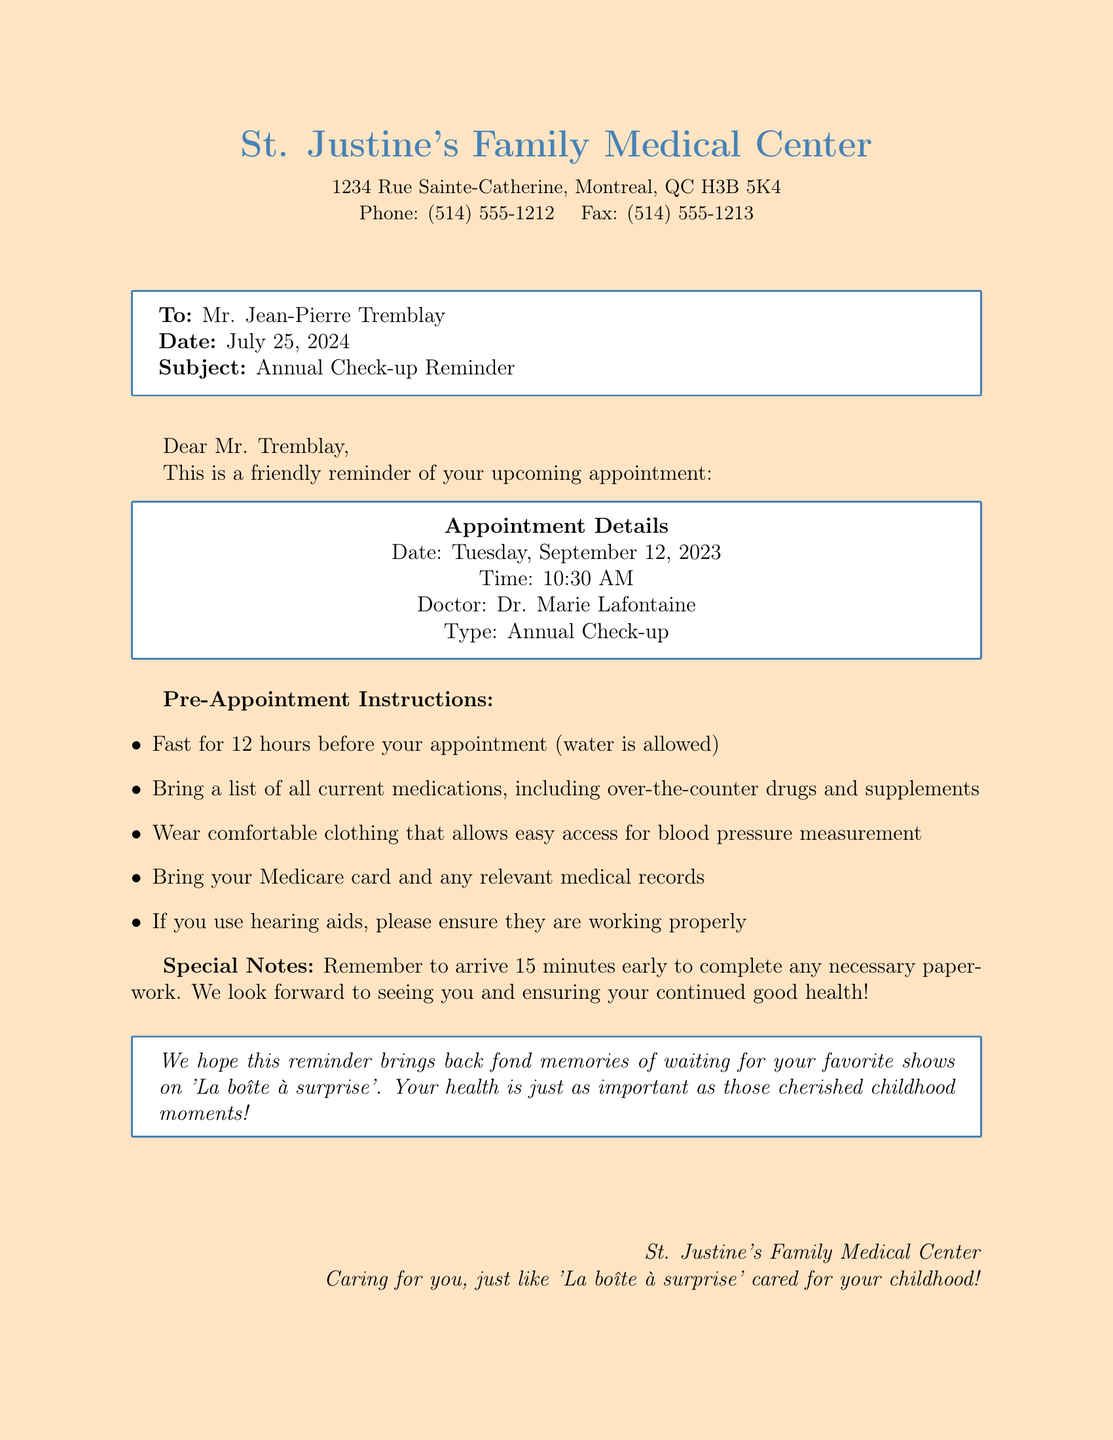what is the name of the doctor? The doctor's name is listed in the appointment details section of the document.
Answer: Dr. Marie Lafontaine what is the appointment date? The appointment date is mentioned in the appointment details section.
Answer: Tuesday, September 12, 2023 how long should you fast before the appointment? The pre-appointment instructions state the fasting duration.
Answer: 12 hours what should you bring to the appointment? The pre-appointment instructions list items to bring; one of them can represent the answer.
Answer: Medicare card how early should you arrive for the appointment? The document specifies the arrival time in the special notes section.
Answer: 15 minutes what type of appointment is it? The type of appointment is indicated in the appointment details section.
Answer: Annual Check-up what is the fax number of St. Justine's Family Medical Center? The fax number is listed at the top of the document.
Answer: (514) 555-1213 what is the address of St. Justine's Family Medical Center? The address is provided in the header of the document.
Answer: 1234 Rue Sainte-Catherine, Montreal, QC H3B 5K4 what should you wear to the appointment? The pre-appointment instructions specify clothing suggestions.
Answer: Comfortable clothing 